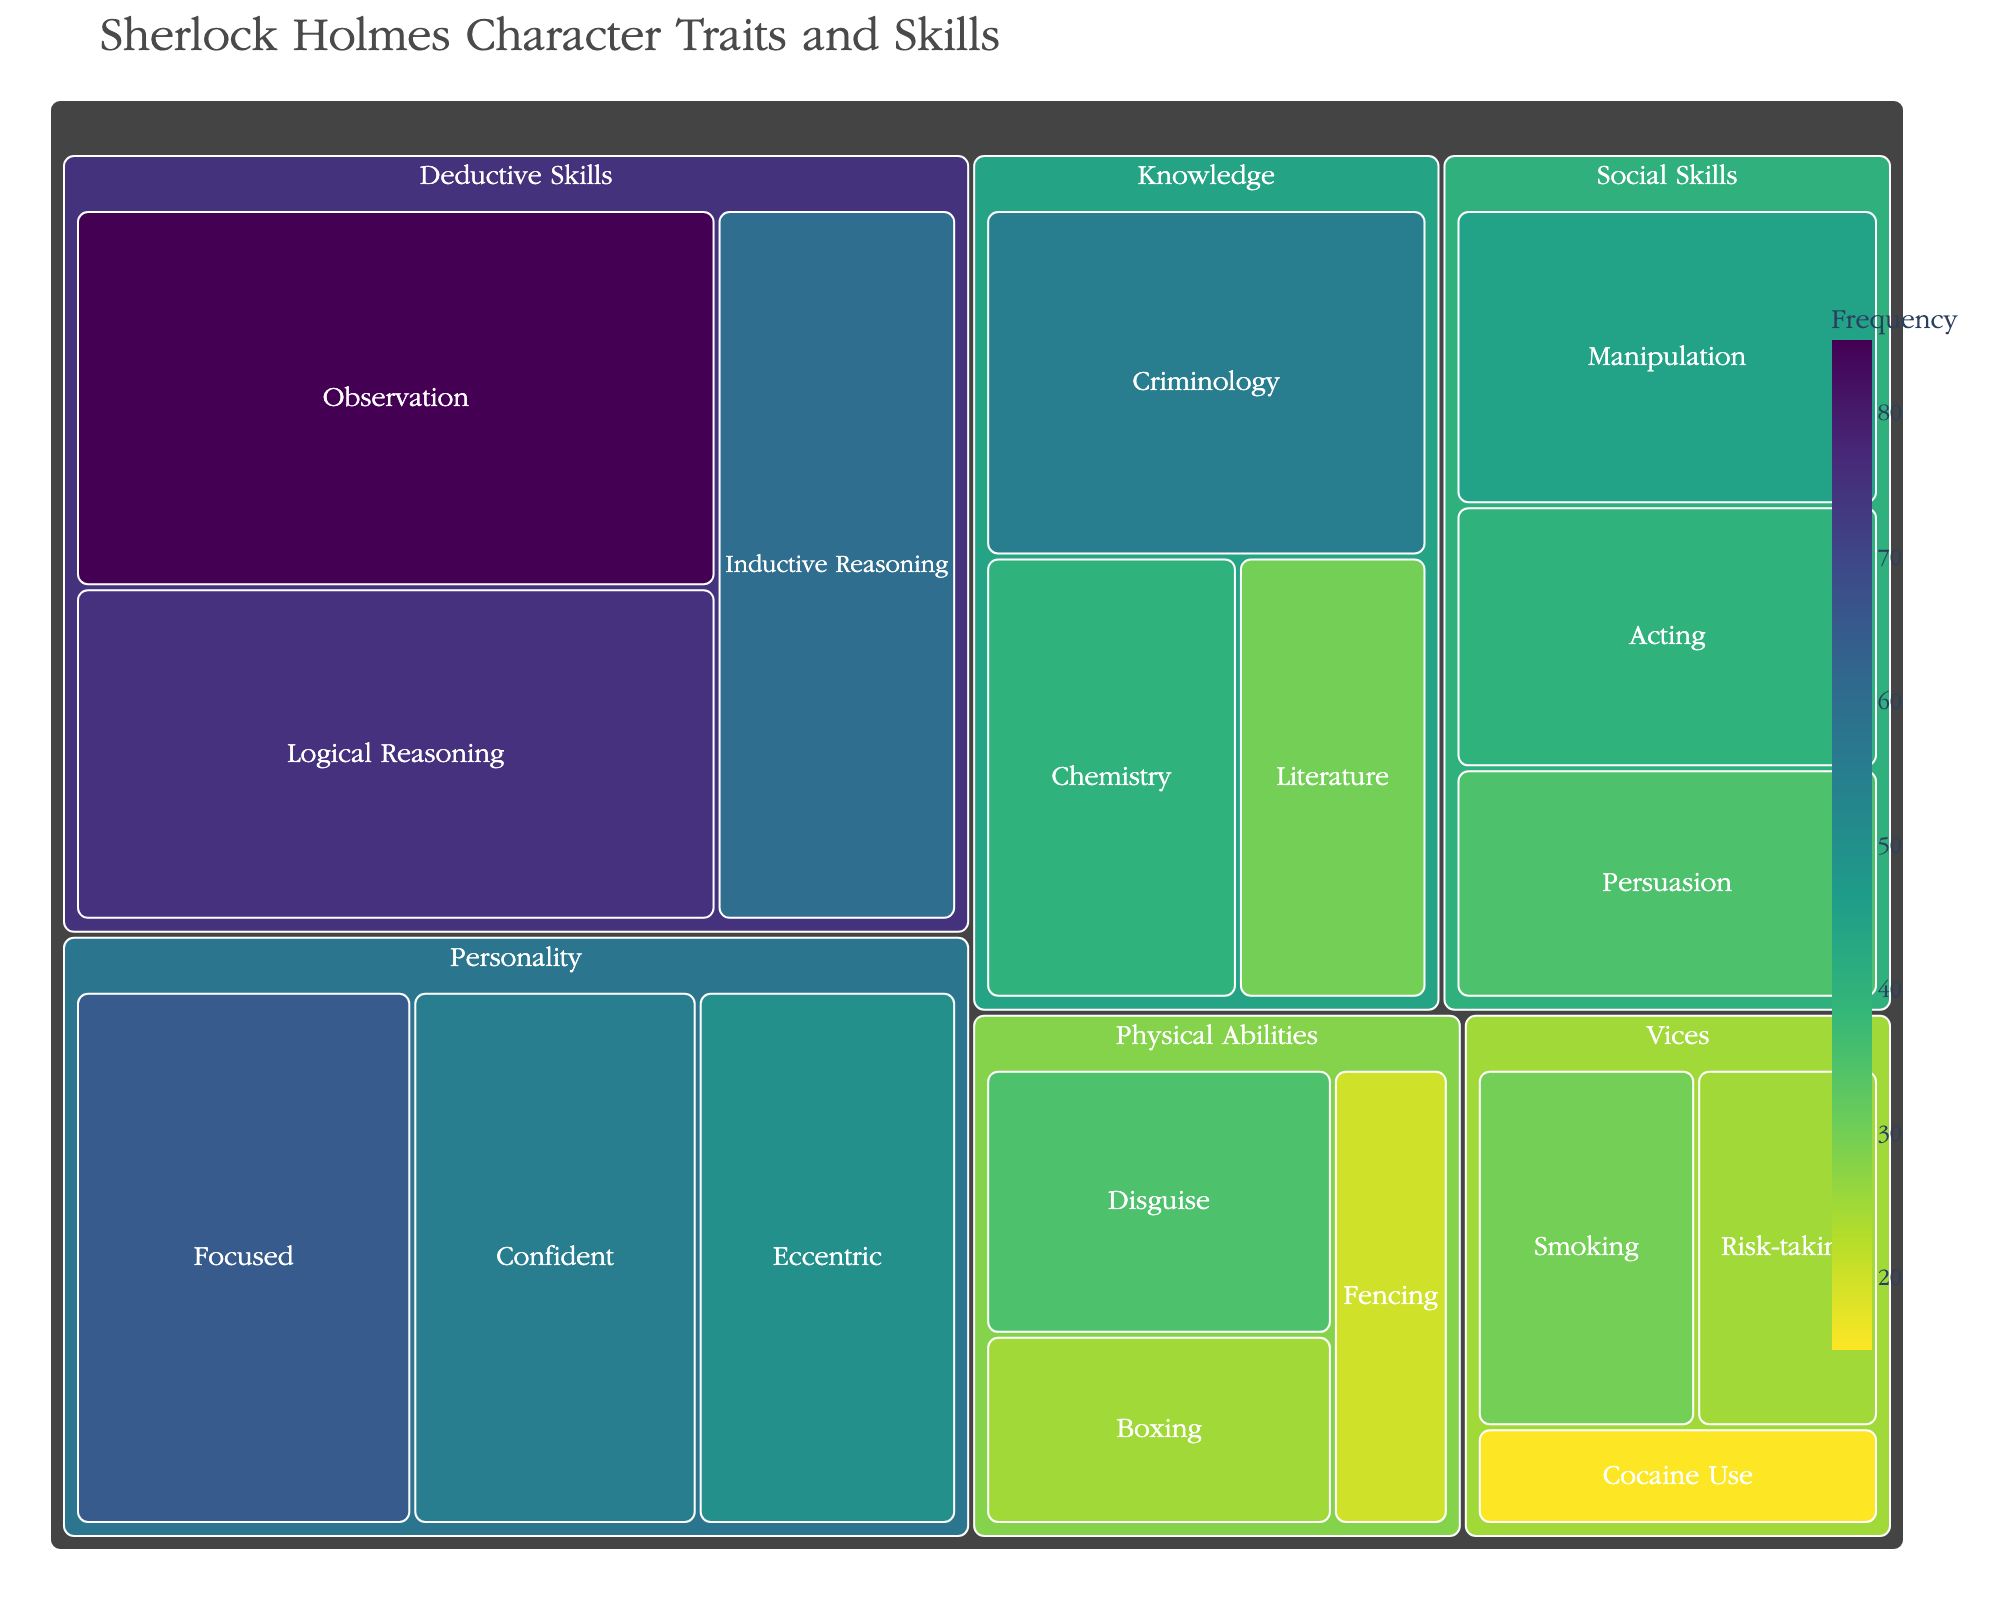What's the most frequently mentioned trait? The most frequently mentioned trait would be the one with the highest frequency value. From the treemap, we see that 'Observation' under 'Deductive Skills' has the highest frequency of 85.
Answer: Observation Which category has the highest total frequency? To identify the category with the highest total frequency, we need to sum the frequencies of all traits in each category. The category 'Deductive Skills' (85 + 75 + 60 = 220) has the highest total frequency compared to other categories.
Answer: Deductive Skills How many traits are there under the 'Physical Abilities' category? The treemap breaks down categories into traits. By counting the traits under the 'Physical Abilities' category, we see there are three traits: Boxing, Fencing, and Disguise.
Answer: 3 Which trait in the 'Personality' category has the lowest frequency? In the 'Personality' category, by checking the frequency values, 'Eccentric' has the lowest frequency, which is 50.
Answer: Eccentric Compare the frequency of 'Smoking' under 'Vices' with 'Disguise' under 'Physical Abilities'. Which is mentioned more frequently? By comparing the frequencies, 'Smoking' has a frequency of 30, whereas 'Disguise' has a frequency of 35. 'Disguise' is mentioned more frequently than 'Smoking'.
Answer: Disguise What's the average frequency of all traits in the 'Social Skills' category? To compute the average, sum the frequencies of all traits in 'Social Skills' and divide by the number of traits. (Manipulation 45 + Acting 40 + Persuasion 35) / 3 = 120 / 3 = 40.
Answer: 40 Which is more frequently mentioned: 'Chemistry' under 'Knowledge' or 'Focused' under 'Personality'? By comparing the frequencies, 'Focused' (65) has a higher frequency than 'Chemistry' (40).
Answer: Focused What is the frequency difference between 'Criminology' under 'Knowledge' and 'Cocaine Use' under 'Vices'? Subtract the frequency of 'Cocaine Use' (15) from 'Criminology' (55): 55 - 15 = 40.
Answer: 40 Is 'Logical Reasoning' under 'Deductive Skills' mentioned more frequently than 'Confident' under 'Personality'? By checking their frequencies, 'Logical Reasoning' has a frequency of 75, while 'Confident' has a frequency of 55. Therefore, 'Logical Reasoning' is mentioned more frequently.
Answer: Yes Which category has traits with the lowest frequency overall? The category with the lowest frequency in terms of traits is 'Vices' as the highest frequency in this category is 30, which is lower than all maximum values in other categories.
Answer: Vices 